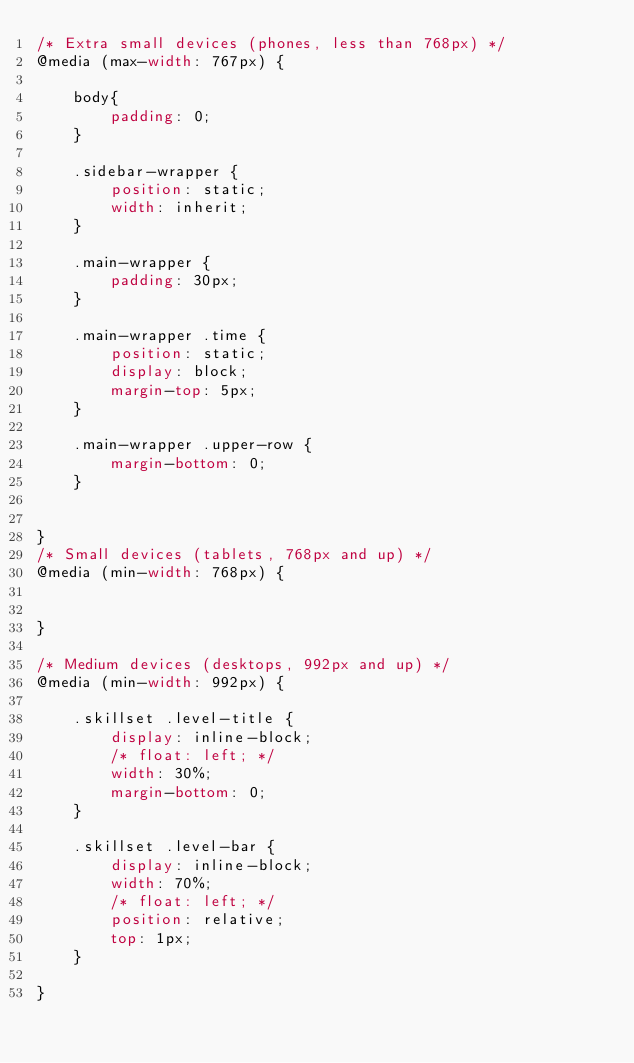<code> <loc_0><loc_0><loc_500><loc_500><_CSS_>/* Extra small devices (phones, less than 768px) */
@media (max-width: 767px) {

    body{
        padding: 0;
    }

    .sidebar-wrapper {
        position: static;
        width: inherit;
    }

    .main-wrapper {
        padding: 30px;
    }

    .main-wrapper .time {
        position: static;
        display: block;
        margin-top: 5px;
    }

    .main-wrapper .upper-row {
        margin-bottom: 0;
    }


}
/* Small devices (tablets, 768px and up) */
@media (min-width: 768px) {


}

/* Medium devices (desktops, 992px and up) */
@media (min-width: 992px) {

    .skillset .level-title {
        display: inline-block;
        /* float: left; */
        width: 30%;
        margin-bottom: 0;
    }

    .skillset .level-bar {
        display: inline-block;
        width: 70%;
        /* float: left; */
        position: relative;
        top: 1px;
    }

}
</code> 